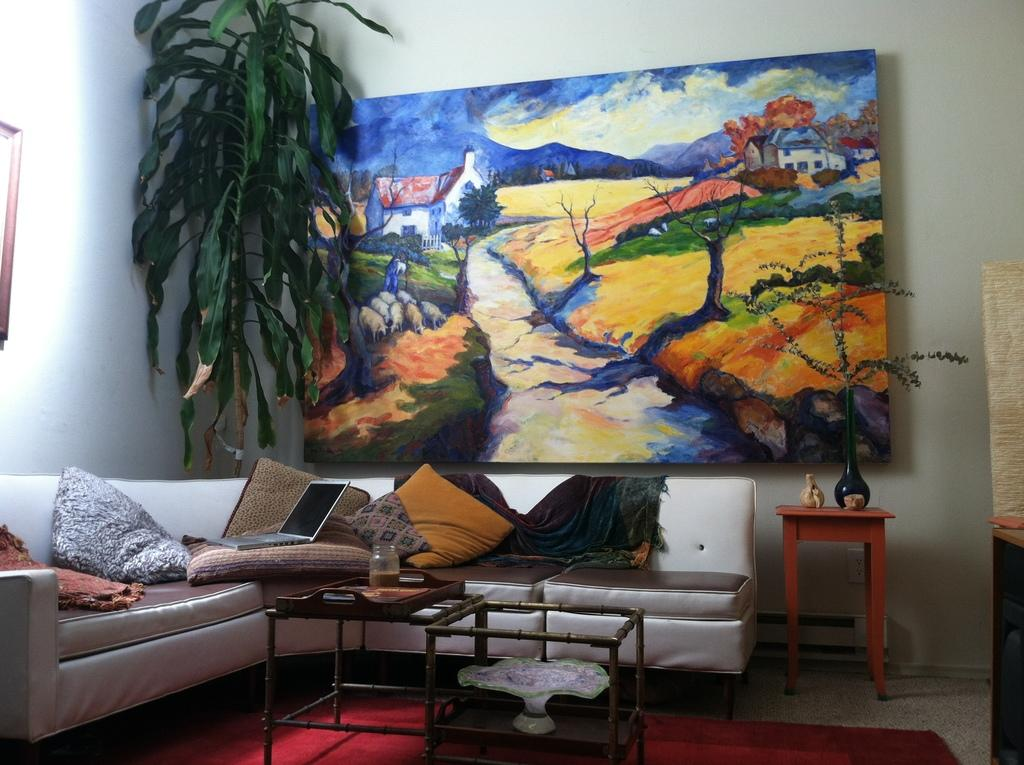What type of furniture is in the image? There is a sofa in the image. What is placed on the sofa? A laptop is present on the sofa. What else can be found on the sofa? There are pillows on the sofa. What is hanging on the wall in the image? There is a scenery on the wall. What color is the carpet on the floor? The floor has a red carpet on it. Where is the toy located in the image? There is no toy present in the image. What type of cup is being used to drink coffee in the image? There is no cup or coffee present in the image. 